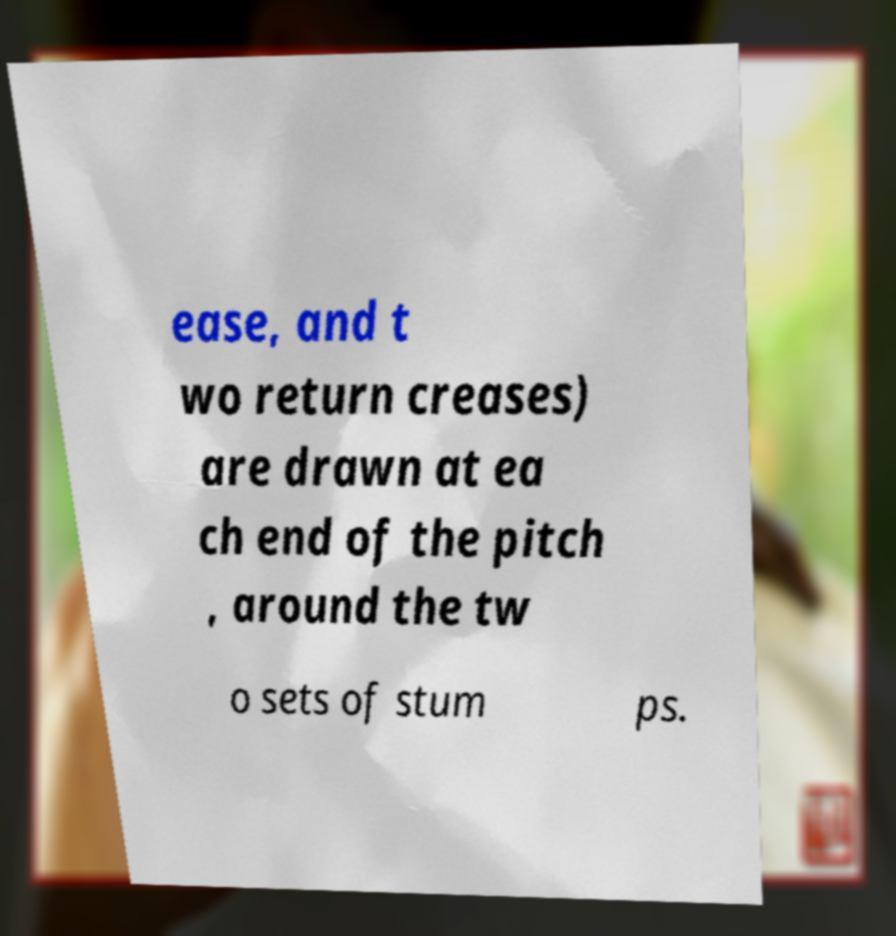Can you accurately transcribe the text from the provided image for me? ease, and t wo return creases) are drawn at ea ch end of the pitch , around the tw o sets of stum ps. 